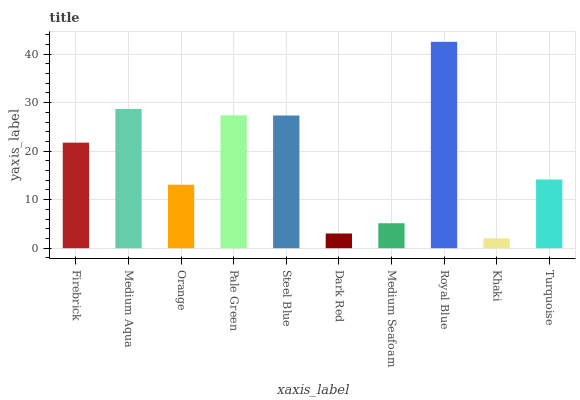Is Khaki the minimum?
Answer yes or no. Yes. Is Royal Blue the maximum?
Answer yes or no. Yes. Is Medium Aqua the minimum?
Answer yes or no. No. Is Medium Aqua the maximum?
Answer yes or no. No. Is Medium Aqua greater than Firebrick?
Answer yes or no. Yes. Is Firebrick less than Medium Aqua?
Answer yes or no. Yes. Is Firebrick greater than Medium Aqua?
Answer yes or no. No. Is Medium Aqua less than Firebrick?
Answer yes or no. No. Is Firebrick the high median?
Answer yes or no. Yes. Is Turquoise the low median?
Answer yes or no. Yes. Is Medium Aqua the high median?
Answer yes or no. No. Is Steel Blue the low median?
Answer yes or no. No. 